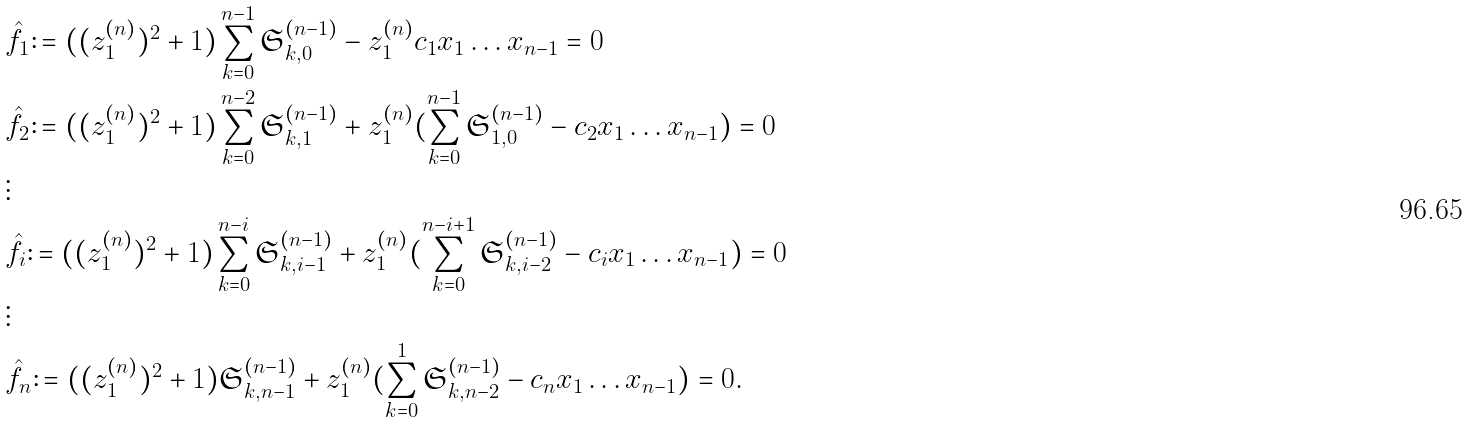Convert formula to latex. <formula><loc_0><loc_0><loc_500><loc_500>& \hat { f } _ { 1 } \colon = ( ( z _ { 1 } ^ { ( n ) } ) ^ { 2 } + 1 ) \sum _ { k = 0 } ^ { n - 1 } \mathfrak { S } ^ { ( n - 1 ) } _ { k , 0 } - z _ { 1 } ^ { ( n ) } c _ { 1 } x _ { 1 } \dots x _ { n - 1 } = 0 \\ & \hat { f } _ { 2 } \colon = ( ( z _ { 1 } ^ { ( n ) } ) ^ { 2 } + 1 ) \sum _ { k = 0 } ^ { n - 2 } \mathfrak { S } ^ { ( n - 1 ) } _ { k , 1 } + z _ { 1 } ^ { ( n ) } ( \sum _ { k = 0 } ^ { n - 1 } \mathfrak { S } ^ { ( n - 1 ) } _ { 1 , 0 } - c _ { 2 } x _ { 1 } \dots x _ { n - 1 } ) = 0 \\ & \vdots \\ & \hat { f } _ { i } \colon = ( ( z _ { 1 } ^ { ( n ) } ) ^ { 2 } + 1 ) \sum _ { k = 0 } ^ { n - i } \mathfrak { S } ^ { ( n - 1 ) } _ { k , i - 1 } + z _ { 1 } ^ { ( n ) } ( \sum _ { k = 0 } ^ { n - i + 1 } \mathfrak { S } ^ { ( n - 1 ) } _ { k , i - 2 } - c _ { i } x _ { 1 } \dots x _ { n - 1 } ) = 0 \\ & \vdots \\ & \hat { f } _ { n } \colon = ( ( z _ { 1 } ^ { ( n ) } ) ^ { 2 } + 1 ) \mathfrak { S } ^ { ( n - 1 ) } _ { k , n - 1 } + z _ { 1 } ^ { ( n ) } ( \sum _ { k = 0 } ^ { 1 } \mathfrak { S } ^ { ( n - 1 ) } _ { k , n - 2 } - c _ { n } x _ { 1 } \dots x _ { n - 1 } ) = 0 .</formula> 